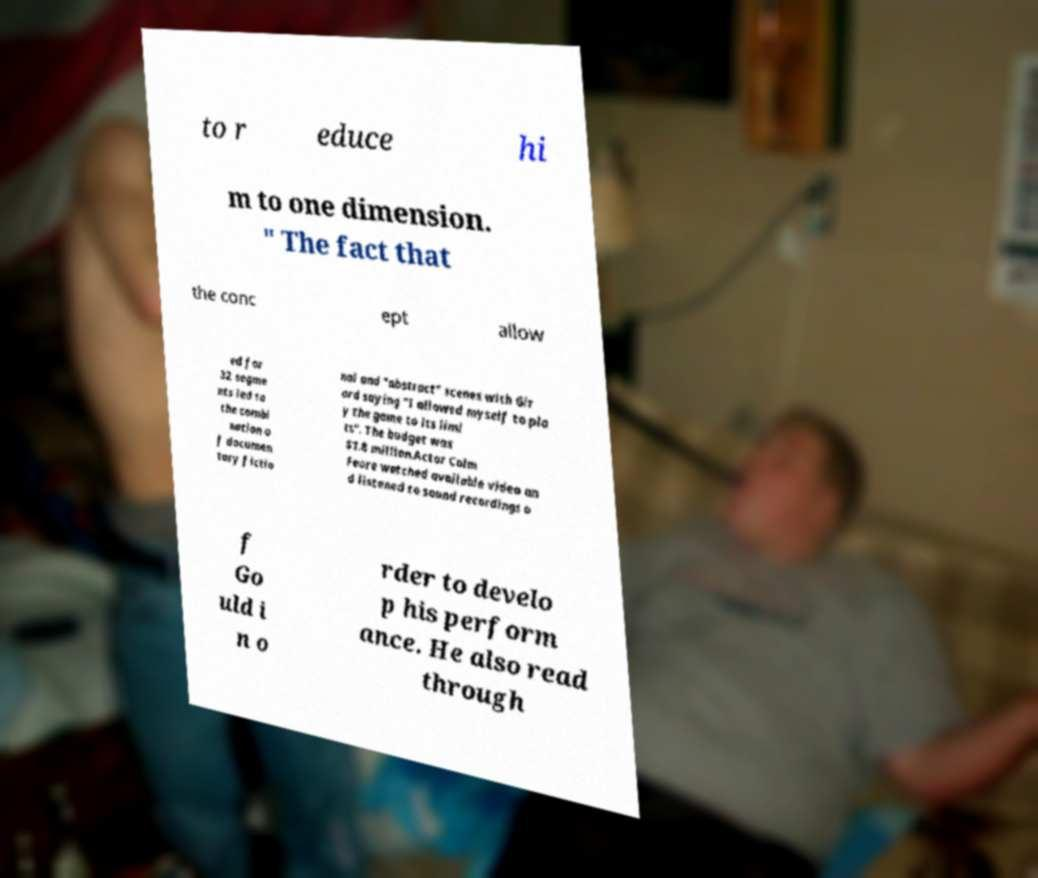There's text embedded in this image that I need extracted. Can you transcribe it verbatim? to r educe hi m to one dimension. " The fact that the conc ept allow ed for 32 segme nts led to the combi nation o f documen tary fictio nal and "abstract" scenes with Gir ard saying "I allowed myself to pla y the game to its limi ts". The budget was $1.8 million.Actor Colm Feore watched available video an d listened to sound recordings o f Go uld i n o rder to develo p his perform ance. He also read through 